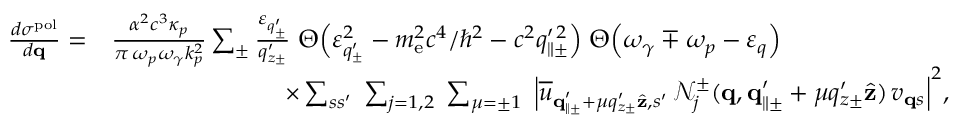<formula> <loc_0><loc_0><loc_500><loc_500>\begin{array} { r l } { \frac { d \sigma ^ { p o l } } { d { q } } = } & { \frac { \alpha ^ { 2 } c ^ { 3 } \kappa _ { p } } { \pi \, \omega _ { p } \omega _ { \gamma } k _ { p } ^ { 2 } } \sum _ { \pm } \frac { \varepsilon _ { q _ { \pm } ^ { \prime } } } { q _ { z \pm } ^ { \prime } } \, \Theta \left ( \varepsilon _ { q _ { \pm } ^ { \prime } } ^ { 2 } - m _ { e } ^ { 2 } c ^ { 4 } / \hbar { ^ } { 2 } - c ^ { 2 } q _ { \| \pm } ^ { \prime \, 2 } \right ) \, \Theta \left ( \omega _ { \gamma } \mp \omega _ { p } - \varepsilon _ { q } \right ) } \\ & { \quad \times \sum _ { s s ^ { \prime } } \, \sum _ { j = 1 , 2 } \, \sum _ { \mu = \pm 1 } \, \left | \overline { u } _ { { q } _ { \| \pm } ^ { \prime } + \mu q _ { z \pm } ^ { \prime } \hat { z } , s ^ { \prime } } \, \mathcal { N } _ { j } ^ { \pm } ( { q } , { q } _ { \| \pm } ^ { \prime } + \mu q _ { z \pm } ^ { \prime } \hat { z } ) \, v _ { { q } s } \right | ^ { 2 } , } \end{array}</formula> 